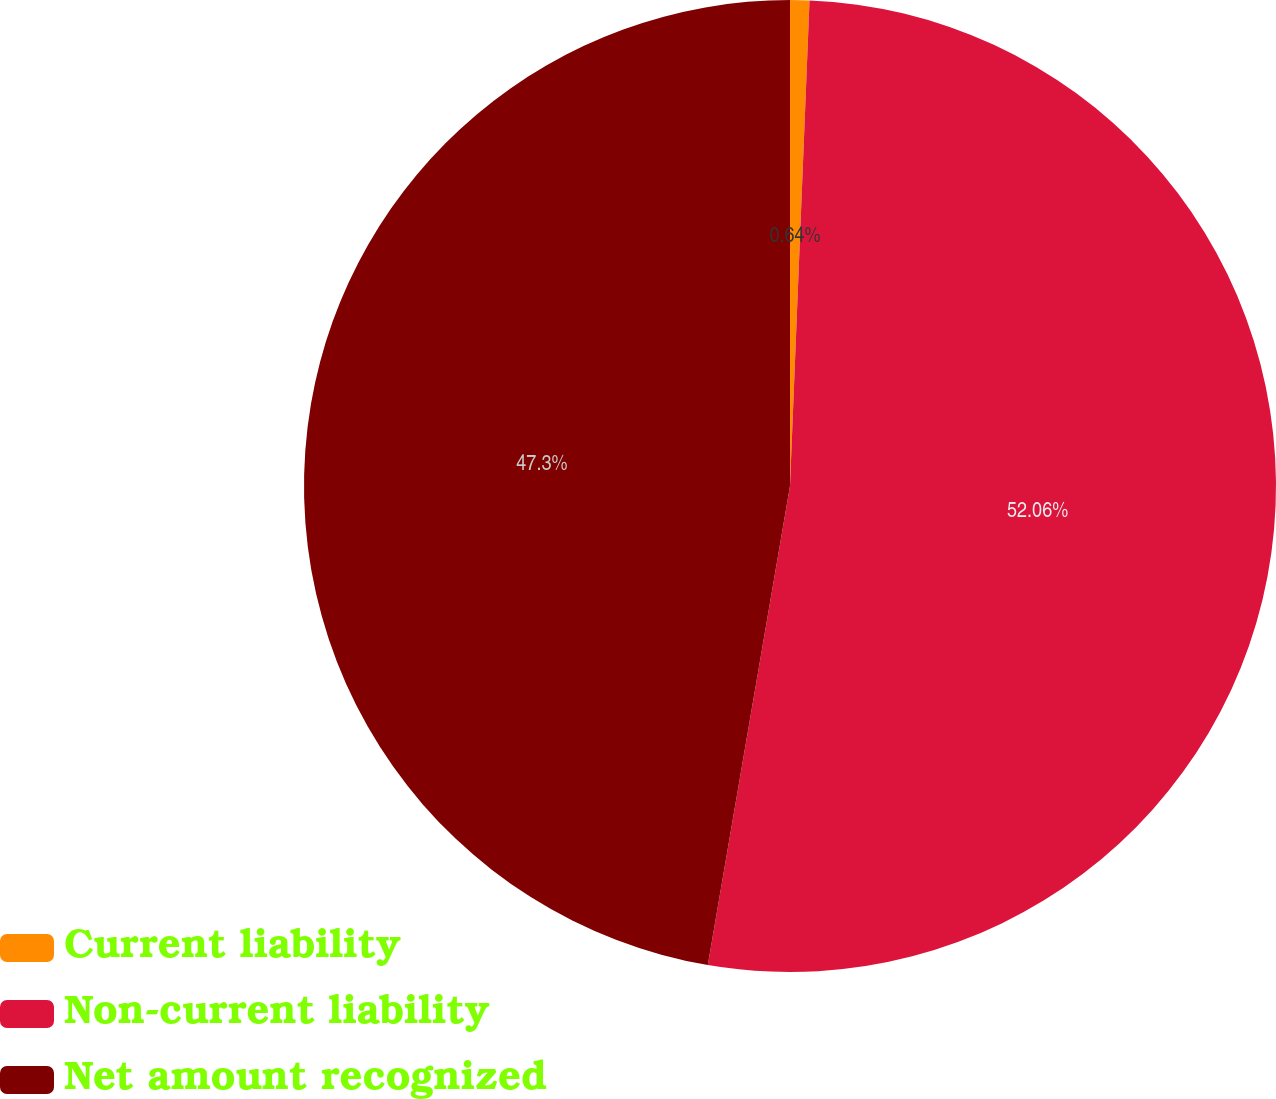<chart> <loc_0><loc_0><loc_500><loc_500><pie_chart><fcel>Current liability<fcel>Non-current liability<fcel>Net amount recognized<nl><fcel>0.64%<fcel>52.07%<fcel>47.3%<nl></chart> 